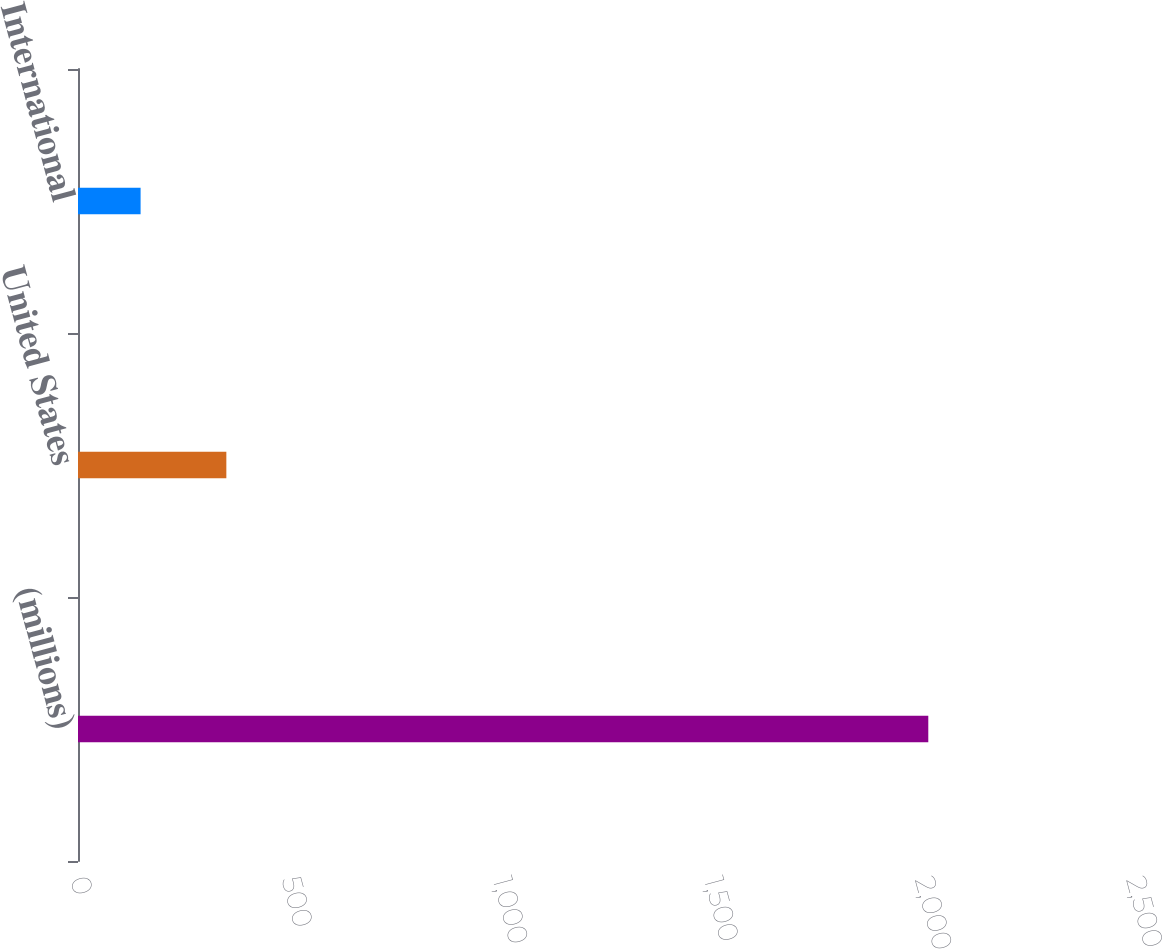<chart> <loc_0><loc_0><loc_500><loc_500><bar_chart><fcel>(millions)<fcel>United States<fcel>International<nl><fcel>2013<fcel>351.2<fcel>148.2<nl></chart> 